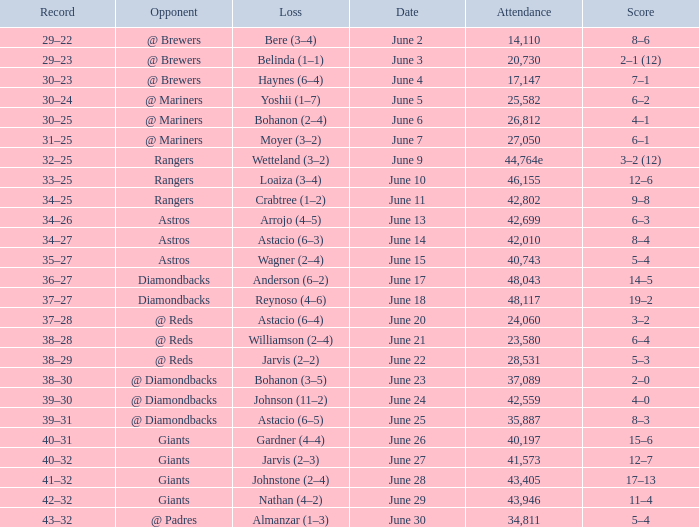Who's the opponent for June 13? Astros. 